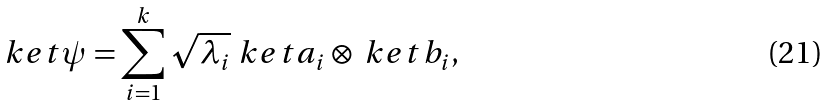<formula> <loc_0><loc_0><loc_500><loc_500>\ k e t { \psi } = \sum _ { i = 1 } ^ { k } \sqrt { \lambda _ { i } } \ k e t { a _ { i } } \otimes \ k e t { b _ { i } } ,</formula> 